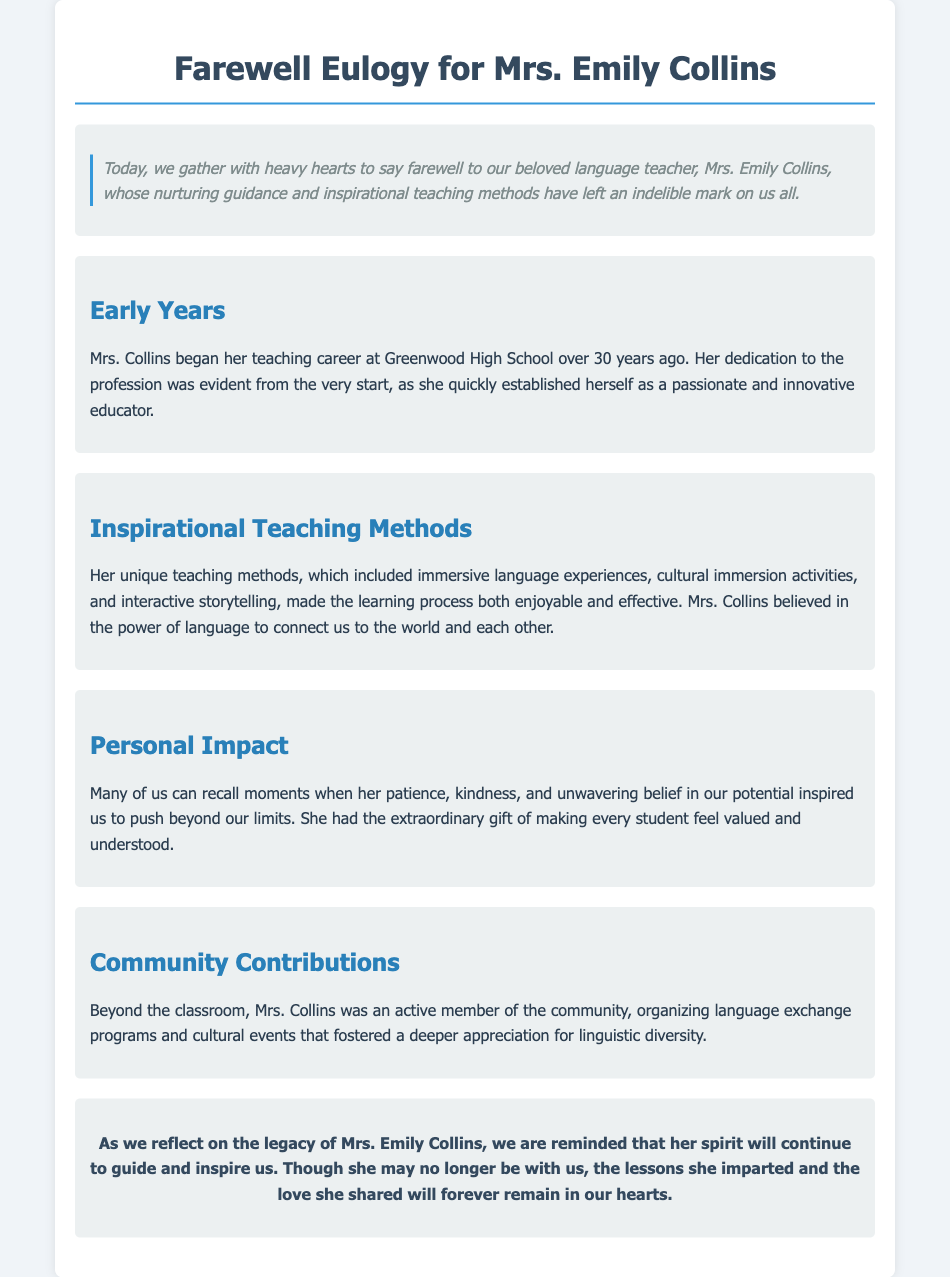What was the name of the teacher being honored? The document frequently mentions the name of the teacher, Mrs. Emily Collins, who is being commemorated.
Answer: Mrs. Emily Collins How many years did Mrs. Collins teach at Greenwood High School? The document states that Mrs. Collins began her teaching career over 30 years ago at Greenwood High School.
Answer: 30 years What unique methods did Mrs. Collins use in her teaching? The document lists immersive language experiences, cultural immersion activities, and interactive storytelling as the unique methods employed by Mrs. Collins.
Answer: Immersive language experiences What qualities did Mrs. Collins exhibit towards her students? The document mentions her patience, kindness, and unwavering belief in her students’ potential as key qualities that she displayed.
Answer: Patience What type of community activities did Mrs. Collins organize? The document notes that she organized language exchange programs and cultural events to promote linguistic diversity.
Answer: Language exchange programs What is the main theme expressed in the eulogy regarding Mrs. Collins' impact? The eulogy reflects on her lasting legacy and the profound impact she had on her students and community.
Answer: Lasting legacy To what extent did Mrs. Collins believe in the power of language? The document explains that she believed language has the power to connect us to the world and to each other, highlighting its significance.
Answer: Connect us to the world What emotional tone does the eulogy convey? The overall tone of the eulogy is one of gratitude and remembrance, reflecting the speaker's deep appreciation for Mrs. Collins' influence.
Answer: Gratitude and remembrance 